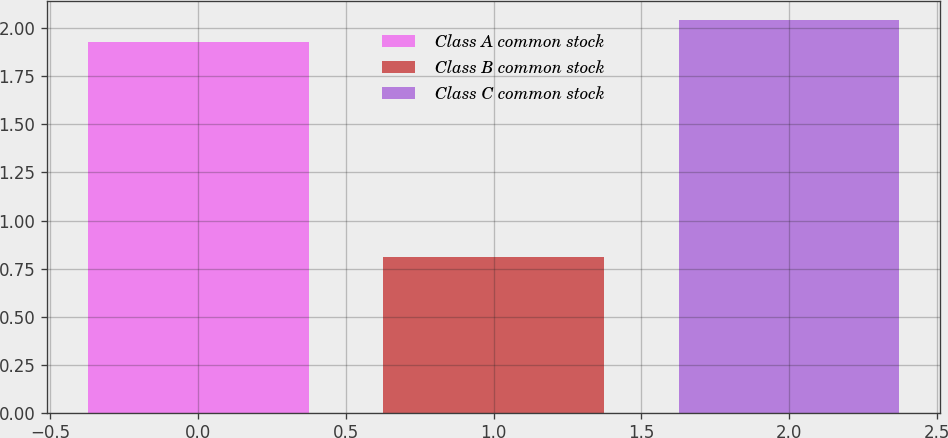<chart> <loc_0><loc_0><loc_500><loc_500><bar_chart><fcel>Class A common stock<fcel>Class B common stock<fcel>Class C common stock<nl><fcel>1.93<fcel>0.81<fcel>2.04<nl></chart> 